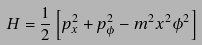<formula> <loc_0><loc_0><loc_500><loc_500>H = \frac { 1 } { 2 } \left [ p _ { x } ^ { 2 } + p _ { \phi } ^ { 2 } - m ^ { 2 } x ^ { 2 } \phi ^ { 2 } \right ]</formula> 